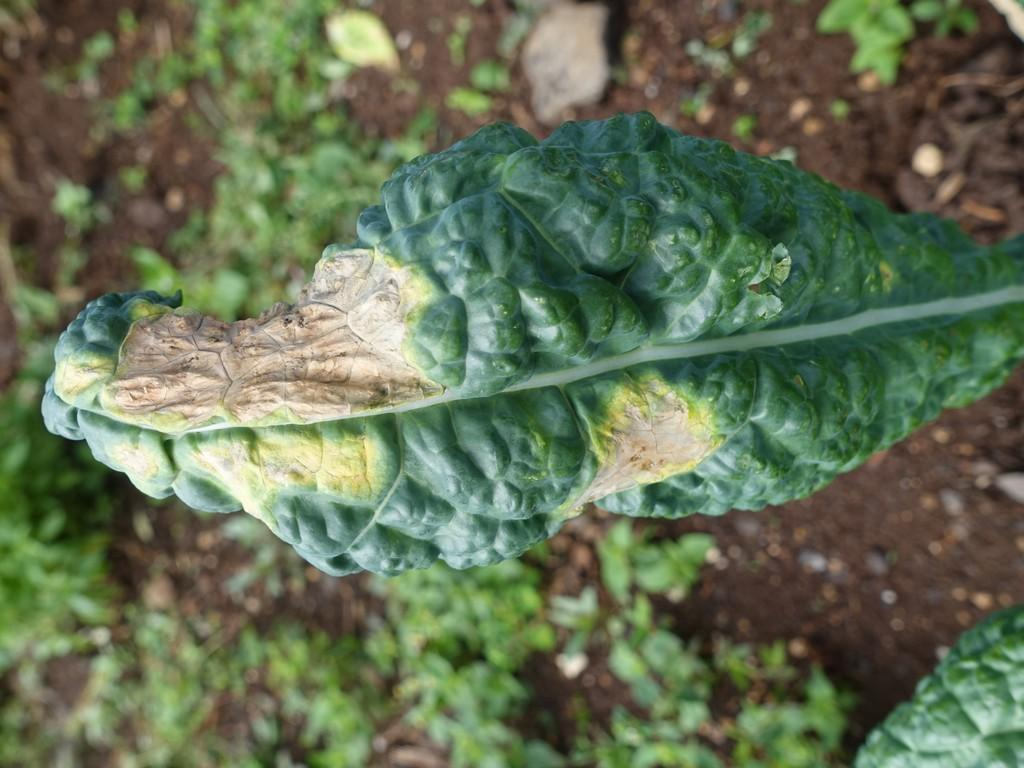What can be seen on the right side of the image? There is a leaf with damaged parts on the right side of the image. What is visible in the background of the image? There are plants on the ground in the background of the image. What color is the silver on the chin of the person in the image? There is no person or silver present in the image; it features a leaf with damaged parts and plants in the background. 